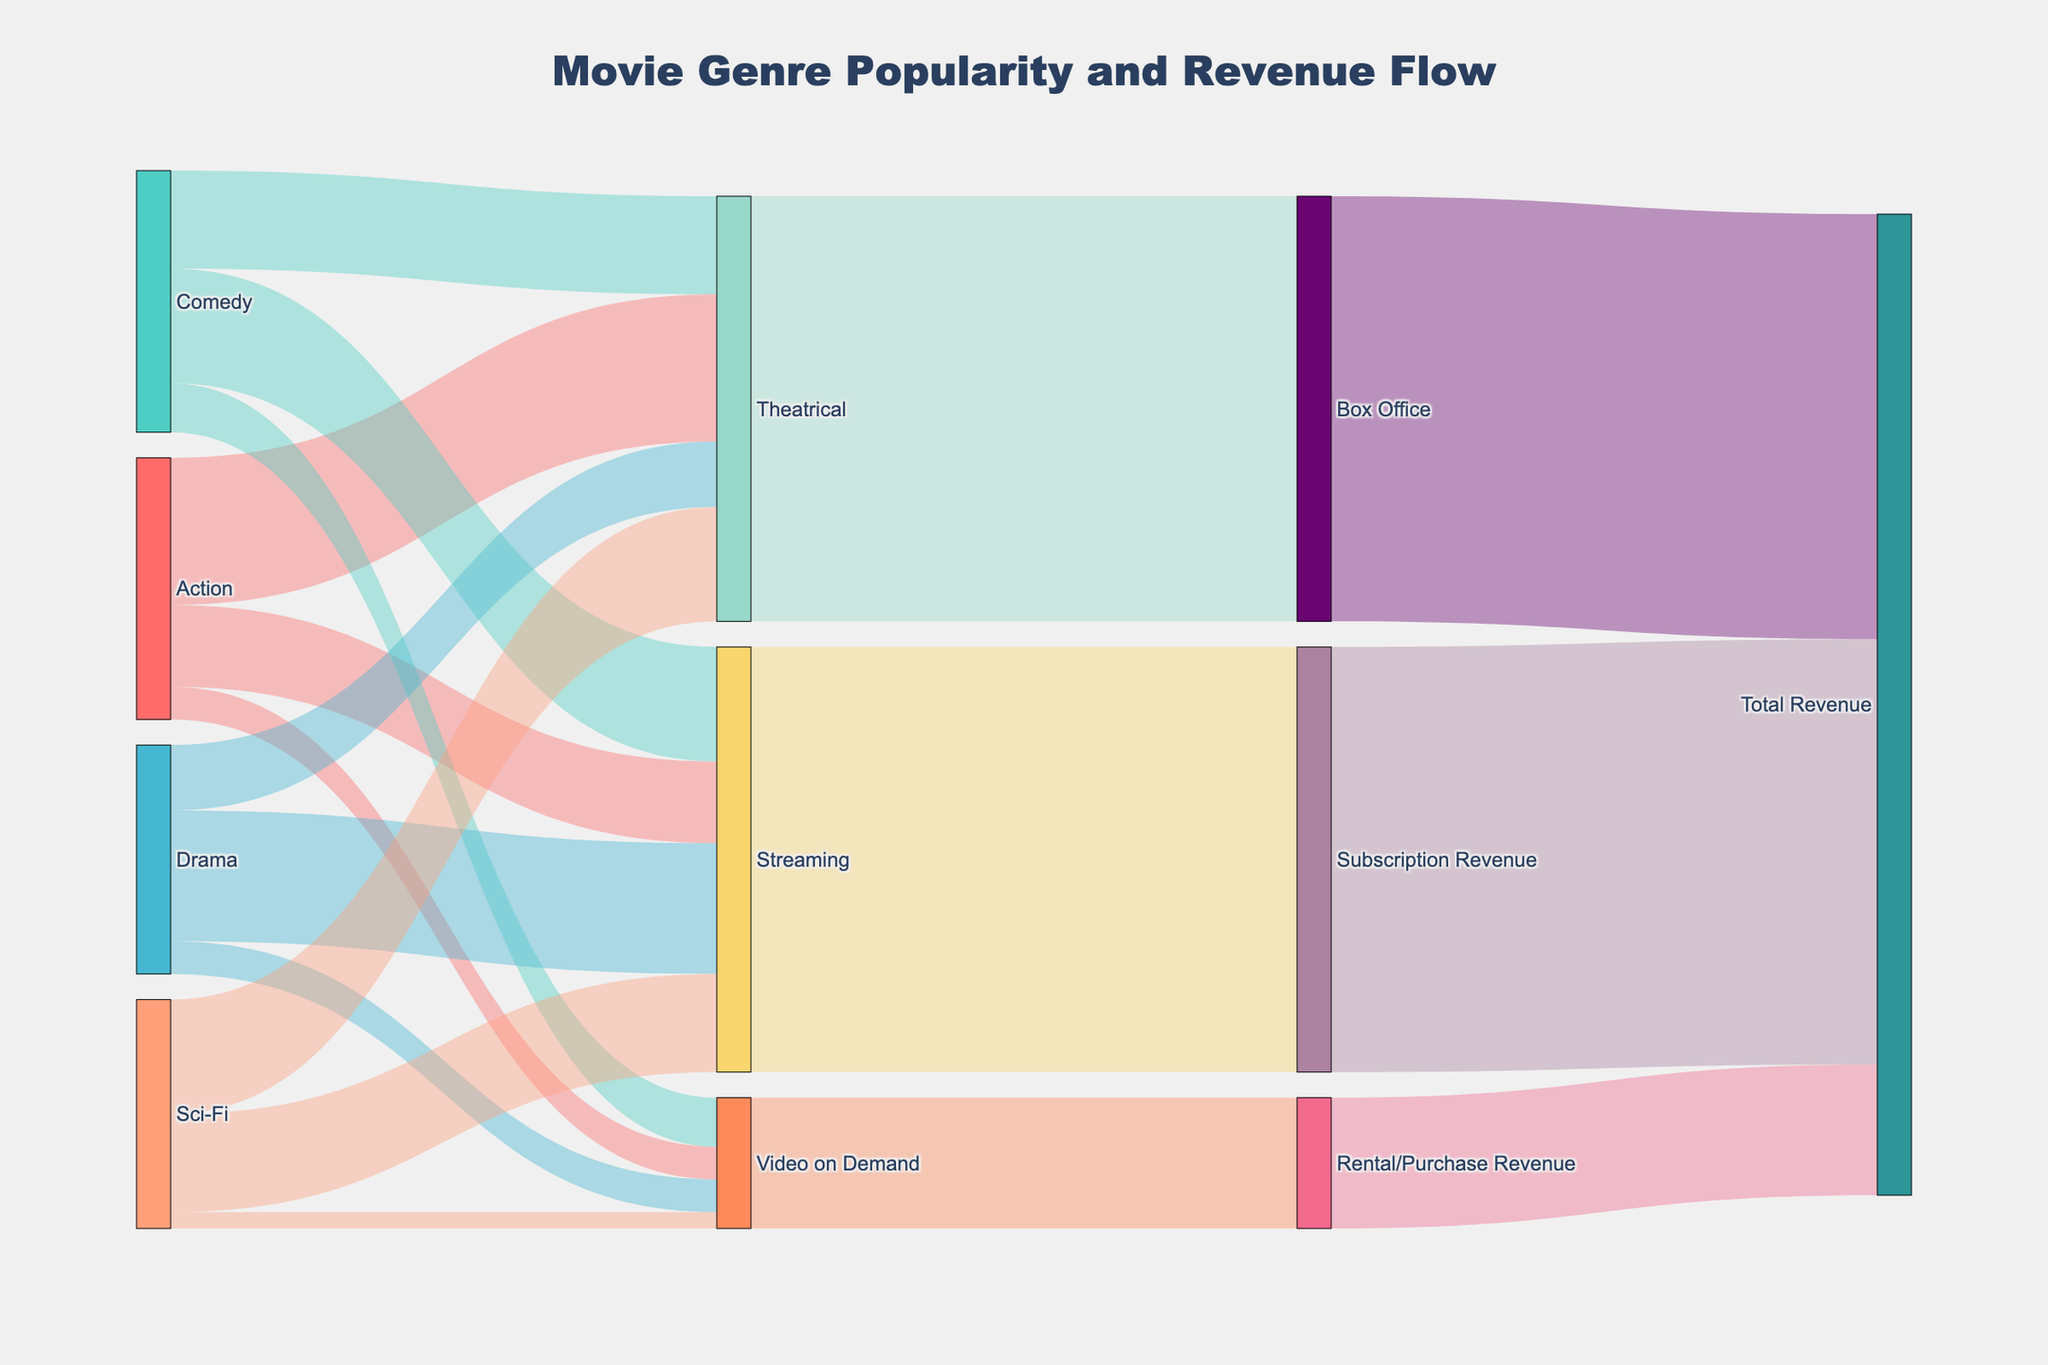what's the total revenue from Box Office? The Sankey Diagram shows a flow from "Box Office" to "Total Revenue." The value corresponding to this flow is 1300.
Answer: 1300 how much revenue does the Drama genre generate from Streaming? There is a flow from "Drama" to "Streaming" with a value of 400. This value represents the revenue generated by the Drama genre from Streaming.
Answer: 400 which genre generates the highest revenue from Theatrical releases? Look at the flows from each genre (Action, Comedy, Drama, Sci-Fi) to "Theatrical." The values are 450 (Action), 300 (Comedy), 200 (Drama), and 350 (Sci-Fi). Action has the highest value of 450.
Answer: Action what's the combined total revenue from Subscription and Rental/Purchase? The flows to "Subscription Revenue" and "Rental/Purchase Revenue" are 1300 and 400, respectively. To find the combined revenue, sum these values: 1300 + 400 = 1700.
Answer: 1700 which outlet generates the least revenue? Compare the outgoing flows from "Theatrical," "Streaming," and "Video on Demand" to the next nodes. The values are 1300 (Theatrical), 1300 (Streaming), and 400 (Video on Demand). Video on Demand generates the least revenue.
Answer: Video on Demand how does the revenue from Video on Demand for the Sci-Fi genre compare to that of the Action genre? The flow from "Sci-Fi" to "Video on Demand" is 50, and from "Action" to "Video on Demand" is 100. The Action genre generates more revenue from Video on Demand than the Sci-Fi genre.
Answer: Action generates more what is the total revenue generated by the Comedy genre across all platforms? The Comedy genre has flows to "Theatrical" (300), "Streaming" (350), and "Video on Demand" (150). Summing these values: 300 + 350 + 150 = 800.
Answer: 800 what proportion of total revenue is from Subscription Revenue? The total revenue is 1300 (Box Office) + 1300 (Subscription Revenue) + 400 (Rental/Purchase Revenue) = 3000. The proportion from Subscription Revenue is 1300 / 3000 = 0.4333, approximately 43.3%.
Answer: 43.3% which platform generates more revenue for the Action genre: Theatrical or Streaming? The flow from "Action" to "Theatrical" is 450, and from "Action" to "Streaming" is 250. Theatrical generates more revenue for the Action genre.
Answer: Theatrical 